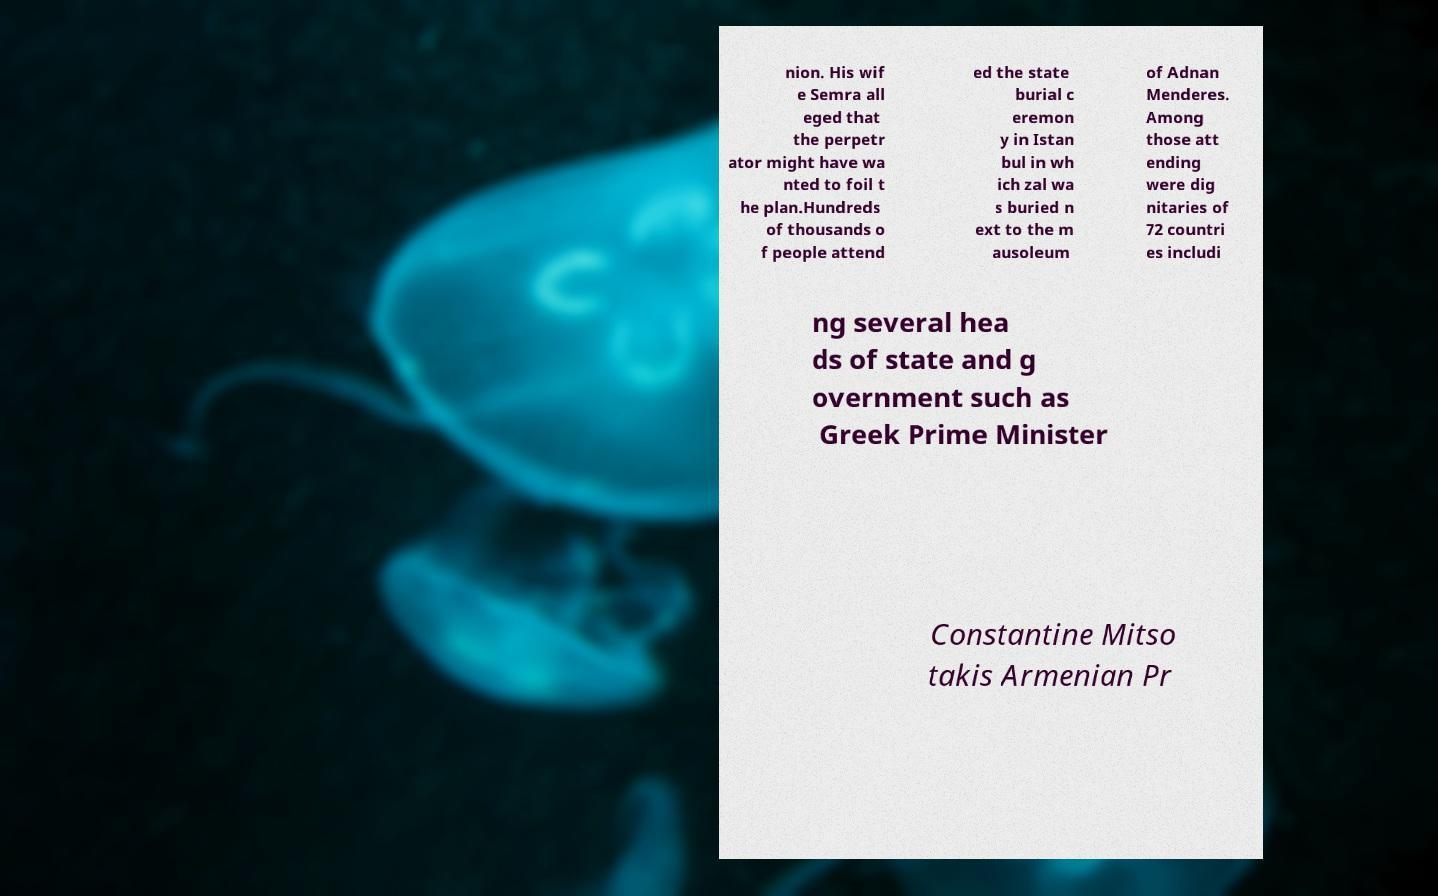What messages or text are displayed in this image? I need them in a readable, typed format. nion. His wif e Semra all eged that the perpetr ator might have wa nted to foil t he plan.Hundreds of thousands o f people attend ed the state burial c eremon y in Istan bul in wh ich zal wa s buried n ext to the m ausoleum of Adnan Menderes. Among those att ending were dig nitaries of 72 countri es includi ng several hea ds of state and g overnment such as Greek Prime Minister Constantine Mitso takis Armenian Pr 